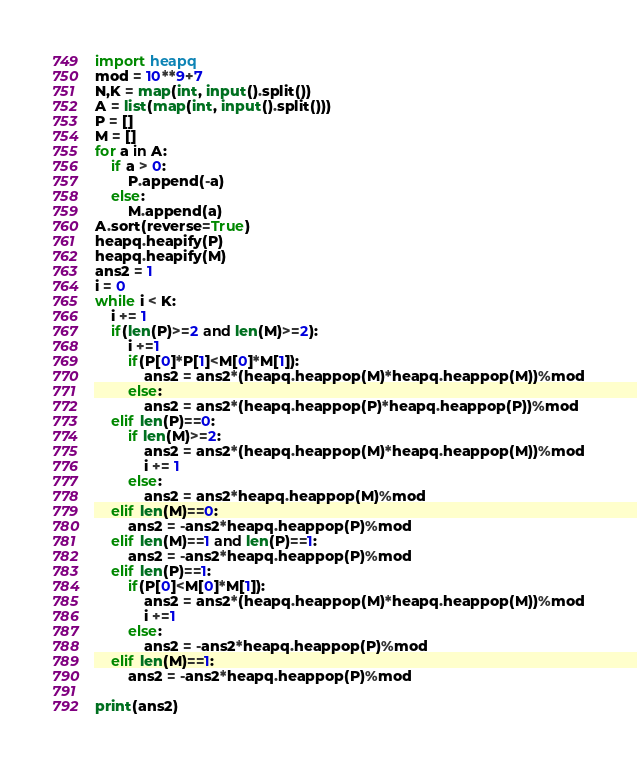<code> <loc_0><loc_0><loc_500><loc_500><_Python_>import heapq
mod = 10**9+7
N,K = map(int, input().split())
A = list(map(int, input().split()))
P = []
M = []
for a in A:
    if a > 0:
        P.append(-a)
    else:
        M.append(a) 
A.sort(reverse=True)
heapq.heapify(P)
heapq.heapify(M)
ans2 = 1
i = 0
while i < K:
    i += 1
    if(len(P)>=2 and len(M)>=2):
        i +=1
        if(P[0]*P[1]<M[0]*M[1]):
            ans2 = ans2*(heapq.heappop(M)*heapq.heappop(M))%mod
        else:
            ans2 = ans2*(heapq.heappop(P)*heapq.heappop(P))%mod
    elif len(P)==0:
        if len(M)>=2:
            ans2 = ans2*(heapq.heappop(M)*heapq.heappop(M))%mod
            i += 1
        else:
            ans2 = ans2*heapq.heappop(M)%mod
    elif len(M)==0:
        ans2 = -ans2*heapq.heappop(P)%mod
    elif len(M)==1 and len(P)==1:
        ans2 = -ans2*heapq.heappop(P)%mod
    elif len(P)==1:
        if(P[0]<M[0]*M[1]):
            ans2 = ans2*(heapq.heappop(M)*heapq.heappop(M))%mod
            i +=1
        else:
            ans2 = -ans2*heapq.heappop(P)%mod
    elif len(M)==1:
        ans2 = -ans2*heapq.heappop(P)%mod

print(ans2)</code> 